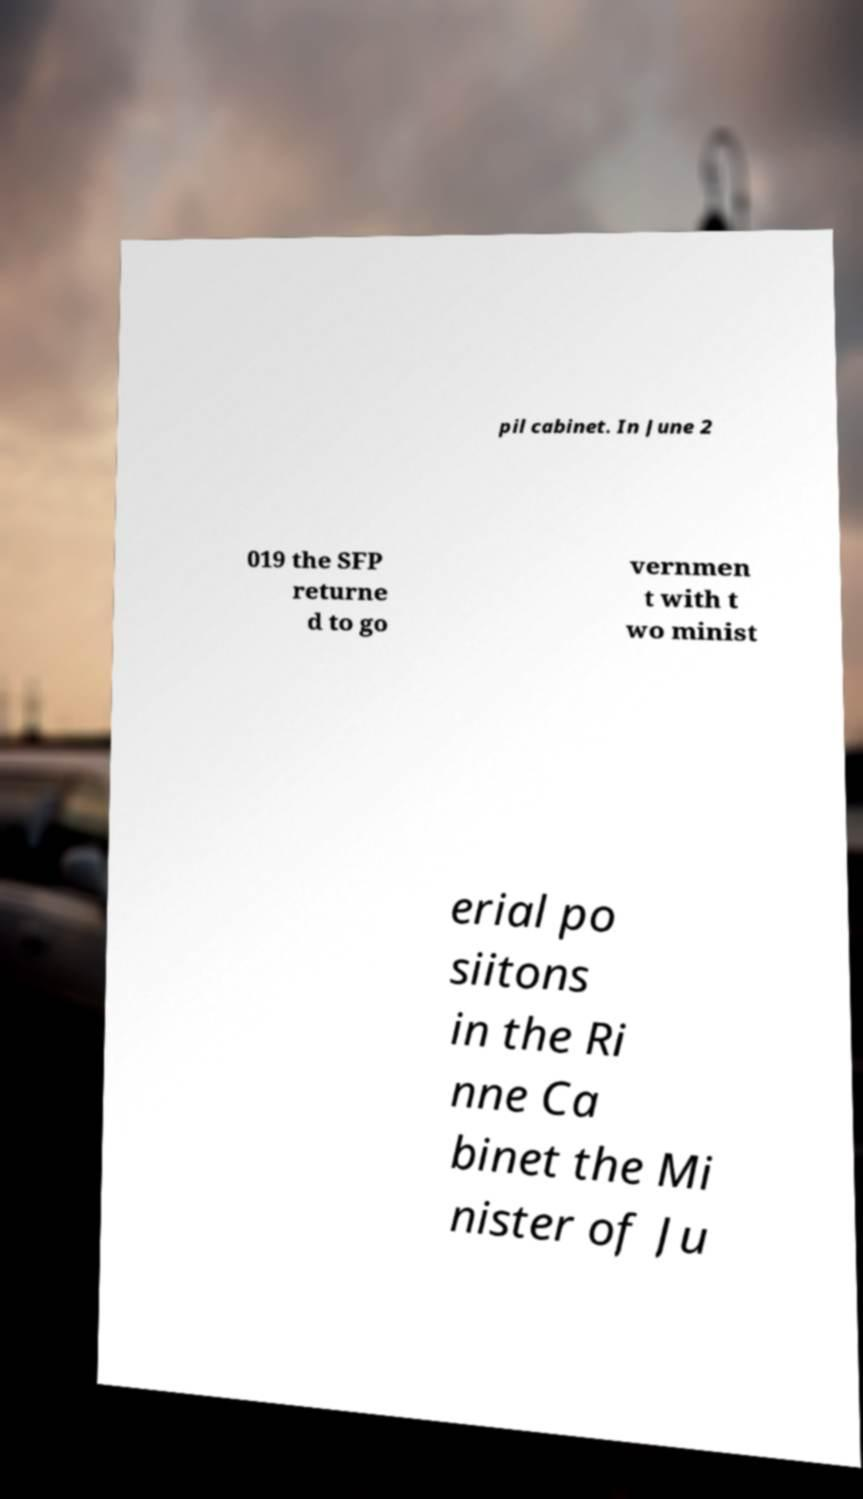Please read and relay the text visible in this image. What does it say? pil cabinet. In June 2 019 the SFP returne d to go vernmen t with t wo minist erial po siitons in the Ri nne Ca binet the Mi nister of Ju 